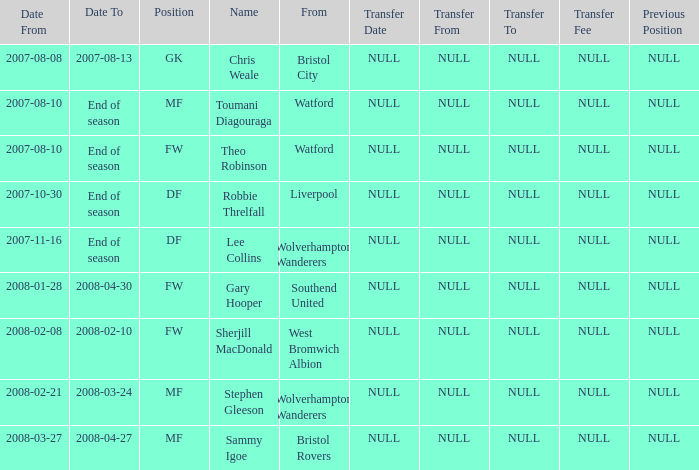On which date did toumani diagouraga, an mf position player, begin? 2007-08-10. 